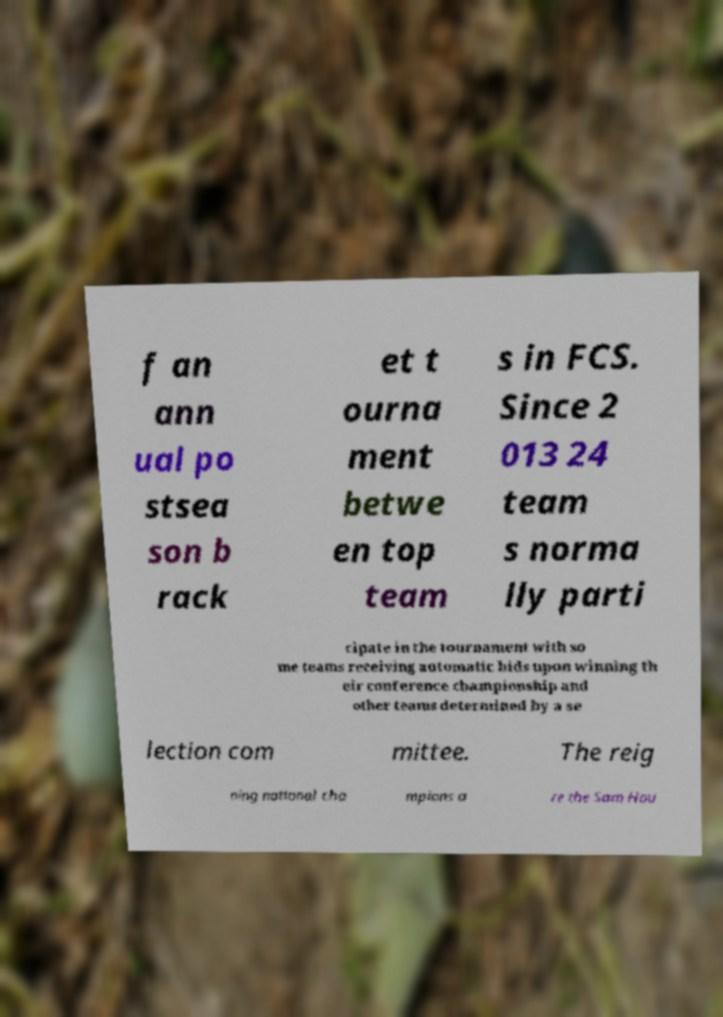Can you read and provide the text displayed in the image?This photo seems to have some interesting text. Can you extract and type it out for me? f an ann ual po stsea son b rack et t ourna ment betwe en top team s in FCS. Since 2 013 24 team s norma lly parti cipate in the tournament with so me teams receiving automatic bids upon winning th eir conference championship and other teams determined by a se lection com mittee. The reig ning national cha mpions a re the Sam Hou 